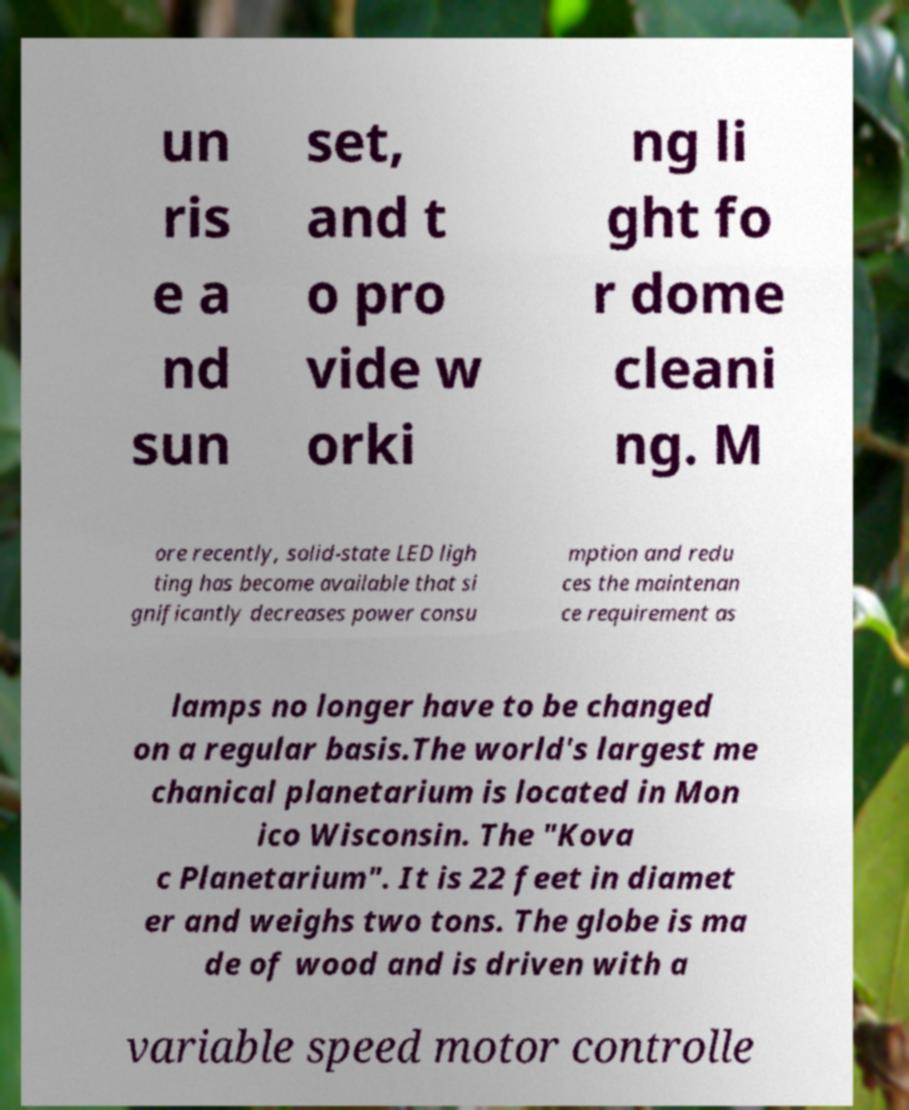I need the written content from this picture converted into text. Can you do that? un ris e a nd sun set, and t o pro vide w orki ng li ght fo r dome cleani ng. M ore recently, solid-state LED ligh ting has become available that si gnificantly decreases power consu mption and redu ces the maintenan ce requirement as lamps no longer have to be changed on a regular basis.The world's largest me chanical planetarium is located in Mon ico Wisconsin. The "Kova c Planetarium". It is 22 feet in diamet er and weighs two tons. The globe is ma de of wood and is driven with a variable speed motor controlle 